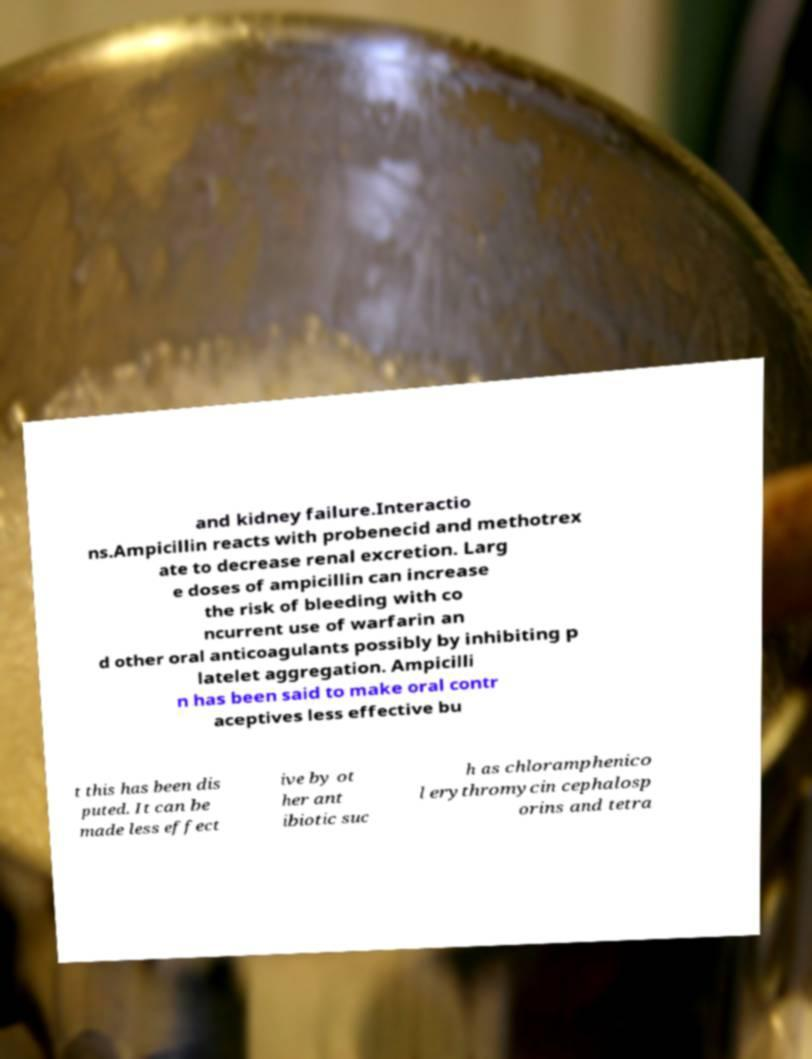I need the written content from this picture converted into text. Can you do that? and kidney failure.Interactio ns.Ampicillin reacts with probenecid and methotrex ate to decrease renal excretion. Larg e doses of ampicillin can increase the risk of bleeding with co ncurrent use of warfarin an d other oral anticoagulants possibly by inhibiting p latelet aggregation. Ampicilli n has been said to make oral contr aceptives less effective bu t this has been dis puted. It can be made less effect ive by ot her ant ibiotic suc h as chloramphenico l erythromycin cephalosp orins and tetra 